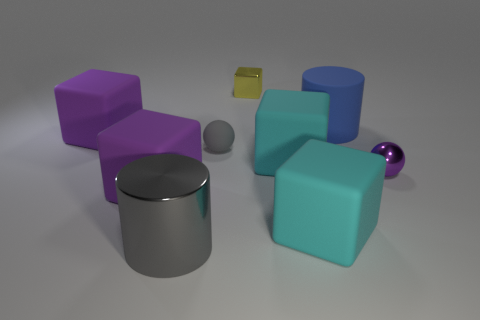There is a ball that is the same color as the big shiny thing; what is it made of?
Provide a succinct answer. Rubber. What number of large shiny cylinders have the same color as the small rubber thing?
Ensure brevity in your answer.  1. There is a cylinder that is the same material as the tiny gray thing; what color is it?
Offer a terse response. Blue. Are there any yellow metal things of the same size as the purple ball?
Provide a short and direct response. Yes. There is another thing that is the same shape as the gray shiny thing; what material is it?
Offer a terse response. Rubber. There is a yellow shiny thing that is the same size as the gray sphere; what is its shape?
Ensure brevity in your answer.  Cube. Is there a purple thing that has the same shape as the small yellow thing?
Give a very brief answer. Yes. There is a big thing behind the large purple cube behind the rubber ball; what is its shape?
Offer a very short reply. Cylinder. The gray rubber thing has what shape?
Your answer should be very brief. Sphere. The cylinder that is in front of the large cyan cube that is on the right side of the large cyan matte block that is behind the shiny sphere is made of what material?
Your answer should be compact. Metal. 